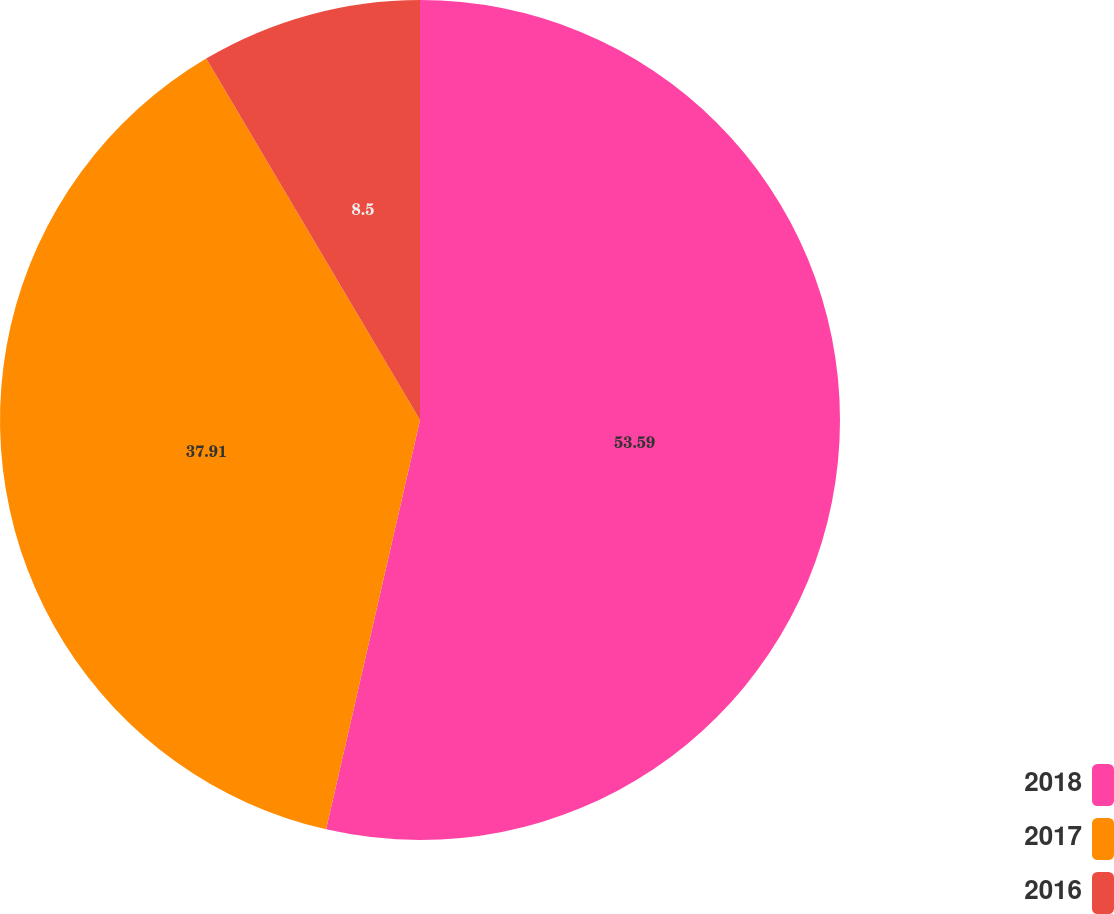Convert chart. <chart><loc_0><loc_0><loc_500><loc_500><pie_chart><fcel>2018<fcel>2017<fcel>2016<nl><fcel>53.59%<fcel>37.91%<fcel>8.5%<nl></chart> 